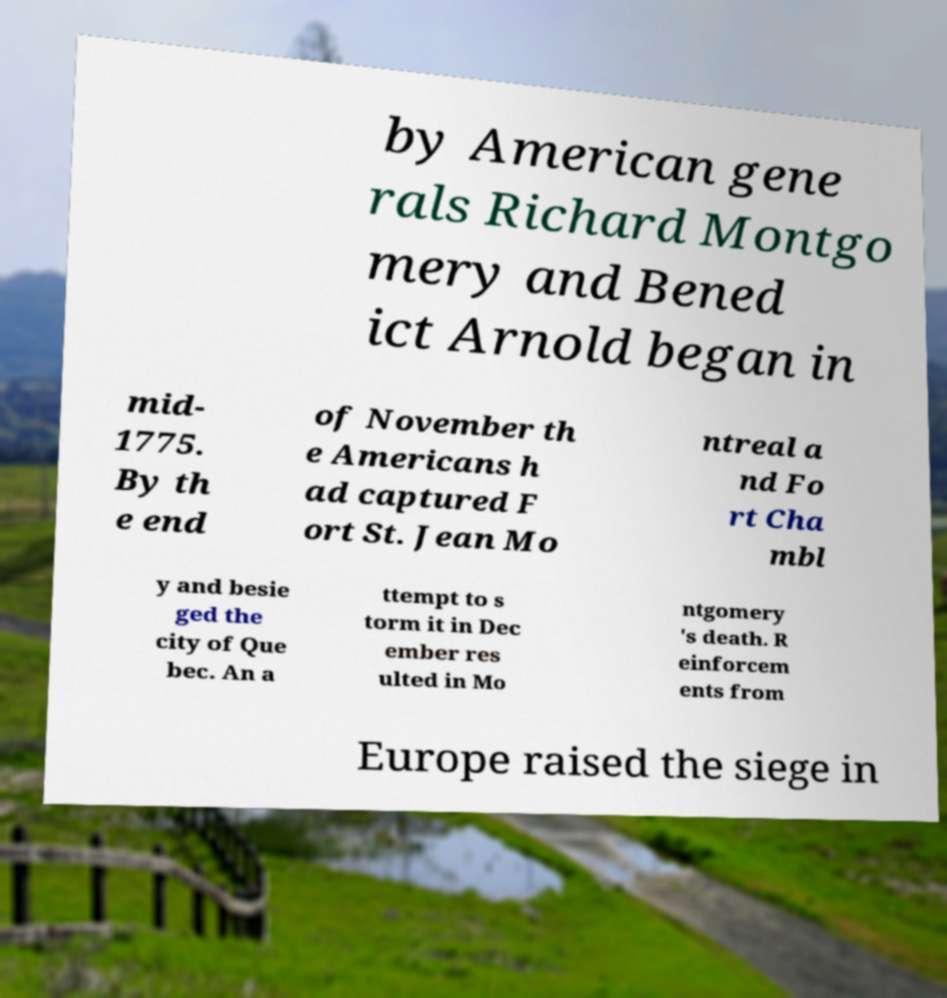What messages or text are displayed in this image? I need them in a readable, typed format. by American gene rals Richard Montgo mery and Bened ict Arnold began in mid- 1775. By th e end of November th e Americans h ad captured F ort St. Jean Mo ntreal a nd Fo rt Cha mbl y and besie ged the city of Que bec. An a ttempt to s torm it in Dec ember res ulted in Mo ntgomery 's death. R einforcem ents from Europe raised the siege in 